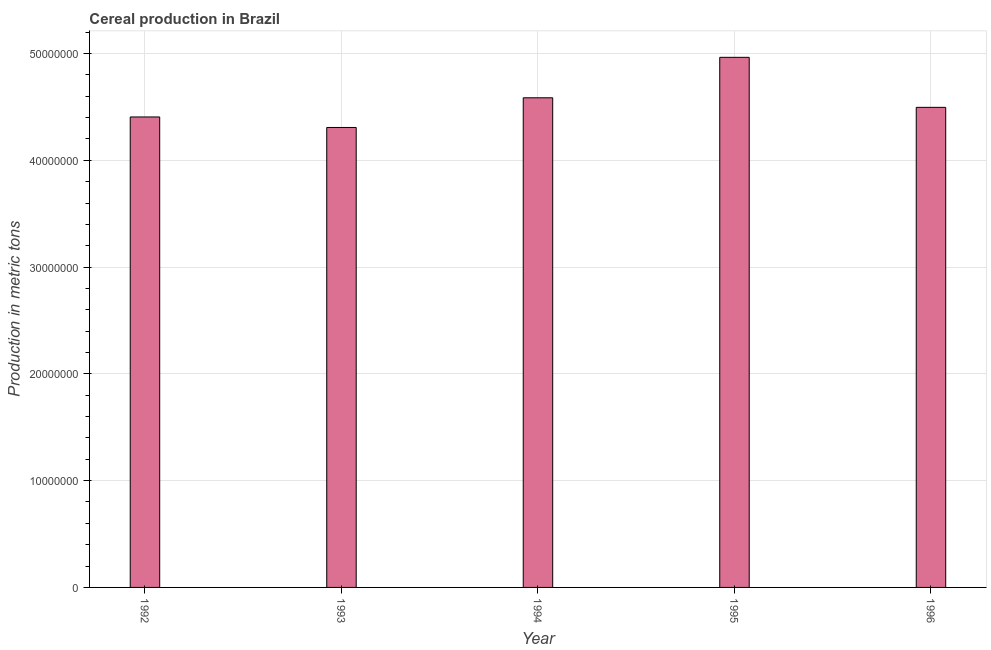What is the title of the graph?
Make the answer very short. Cereal production in Brazil. What is the label or title of the X-axis?
Your answer should be compact. Year. What is the label or title of the Y-axis?
Your answer should be very brief. Production in metric tons. What is the cereal production in 1996?
Your response must be concise. 4.50e+07. Across all years, what is the maximum cereal production?
Keep it short and to the point. 4.96e+07. Across all years, what is the minimum cereal production?
Keep it short and to the point. 4.31e+07. In which year was the cereal production minimum?
Provide a short and direct response. 1993. What is the sum of the cereal production?
Ensure brevity in your answer.  2.28e+08. What is the difference between the cereal production in 1993 and 1996?
Your answer should be very brief. -1.88e+06. What is the average cereal production per year?
Make the answer very short. 4.55e+07. What is the median cereal production?
Keep it short and to the point. 4.50e+07. In how many years, is the cereal production greater than 24000000 metric tons?
Your answer should be very brief. 5. What is the ratio of the cereal production in 1995 to that in 1996?
Your response must be concise. 1.1. Is the difference between the cereal production in 1992 and 1995 greater than the difference between any two years?
Make the answer very short. No. What is the difference between the highest and the second highest cereal production?
Your response must be concise. 3.79e+06. What is the difference between the highest and the lowest cereal production?
Provide a succinct answer. 6.57e+06. How many bars are there?
Provide a succinct answer. 5. What is the Production in metric tons of 1992?
Ensure brevity in your answer.  4.41e+07. What is the Production in metric tons in 1993?
Make the answer very short. 4.31e+07. What is the Production in metric tons in 1994?
Ensure brevity in your answer.  4.59e+07. What is the Production in metric tons of 1995?
Ensure brevity in your answer.  4.96e+07. What is the Production in metric tons of 1996?
Make the answer very short. 4.50e+07. What is the difference between the Production in metric tons in 1992 and 1993?
Keep it short and to the point. 9.85e+05. What is the difference between the Production in metric tons in 1992 and 1994?
Ensure brevity in your answer.  -1.79e+06. What is the difference between the Production in metric tons in 1992 and 1995?
Your answer should be very brief. -5.58e+06. What is the difference between the Production in metric tons in 1992 and 1996?
Your answer should be very brief. -8.99e+05. What is the difference between the Production in metric tons in 1993 and 1994?
Make the answer very short. -2.78e+06. What is the difference between the Production in metric tons in 1993 and 1995?
Ensure brevity in your answer.  -6.57e+06. What is the difference between the Production in metric tons in 1993 and 1996?
Offer a very short reply. -1.88e+06. What is the difference between the Production in metric tons in 1994 and 1995?
Your answer should be very brief. -3.79e+06. What is the difference between the Production in metric tons in 1994 and 1996?
Give a very brief answer. 8.96e+05. What is the difference between the Production in metric tons in 1995 and 1996?
Keep it short and to the point. 4.68e+06. What is the ratio of the Production in metric tons in 1992 to that in 1993?
Provide a succinct answer. 1.02. What is the ratio of the Production in metric tons in 1992 to that in 1994?
Your answer should be very brief. 0.96. What is the ratio of the Production in metric tons in 1992 to that in 1995?
Keep it short and to the point. 0.89. What is the ratio of the Production in metric tons in 1993 to that in 1994?
Offer a terse response. 0.94. What is the ratio of the Production in metric tons in 1993 to that in 1995?
Provide a succinct answer. 0.87. What is the ratio of the Production in metric tons in 1993 to that in 1996?
Offer a terse response. 0.96. What is the ratio of the Production in metric tons in 1994 to that in 1995?
Provide a short and direct response. 0.92. What is the ratio of the Production in metric tons in 1995 to that in 1996?
Ensure brevity in your answer.  1.1. 